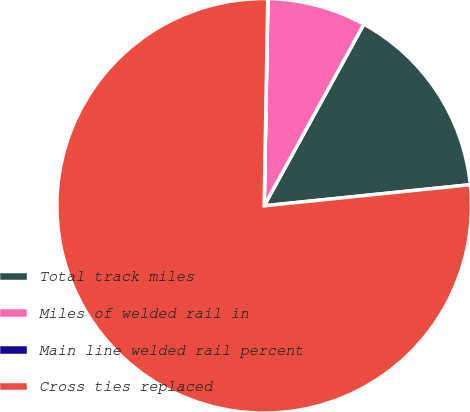Convert chart. <chart><loc_0><loc_0><loc_500><loc_500><pie_chart><fcel>Total track miles<fcel>Miles of welded rail in<fcel>Main line welded rail percent<fcel>Cross ties replaced<nl><fcel>15.39%<fcel>7.7%<fcel>0.01%<fcel>76.91%<nl></chart> 